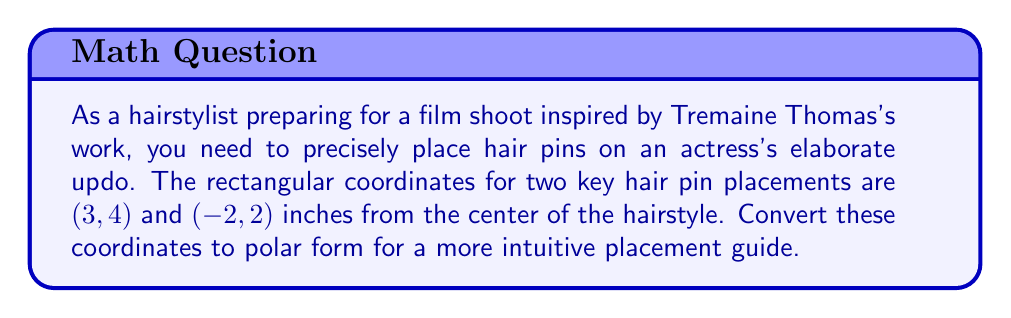What is the answer to this math problem? To convert rectangular coordinates $(x, y)$ to polar coordinates $(r, \theta)$, we use the following formulas:

1. $r = \sqrt{x^2 + y^2}$
2. $\theta = \tan^{-1}(\frac{y}{x})$

For the first point (3, 4):

1. Calculate $r$:
   $r = \sqrt{3^2 + 4^2} = \sqrt{9 + 16} = \sqrt{25} = 5$ inches

2. Calculate $\theta$:
   $\theta = \tan^{-1}(\frac{4}{3}) \approx 0.9273$ radians
   
   To convert to degrees: $0.9273 \times \frac{180°}{\pi} \approx 53.13°$

For the second point (-2, 2):

1. Calculate $r$:
   $r = \sqrt{(-2)^2 + 2^2} = \sqrt{4 + 4} = \sqrt{8} = 2\sqrt{2}$ inches

2. Calculate $\theta$:
   $\theta = \tan^{-1}(\frac{2}{-2}) = \tan^{-1}(-1) = -\frac{\pi}{4}$ radians
   
   However, since this point is in the second quadrant, we need to add $\pi$ to the result:
   $\theta = -\frac{\pi}{4} + \pi = \frac{3\pi}{4}$ radians
   
   To convert to degrees: $\frac{3\pi}{4} \times \frac{180°}{\pi} = 135°$
Answer: The polar coordinates are:
(3, 4) → $(5, 53.13°)$
(-2, 2) → $(2\sqrt{2}, 135°)$ 